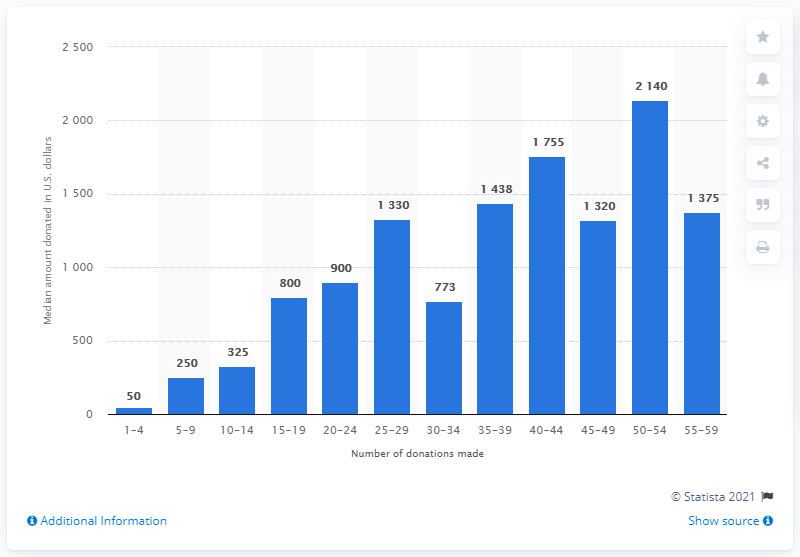Point out several critical features in this image. In 2015, the median yearly giving per donor was $50. 